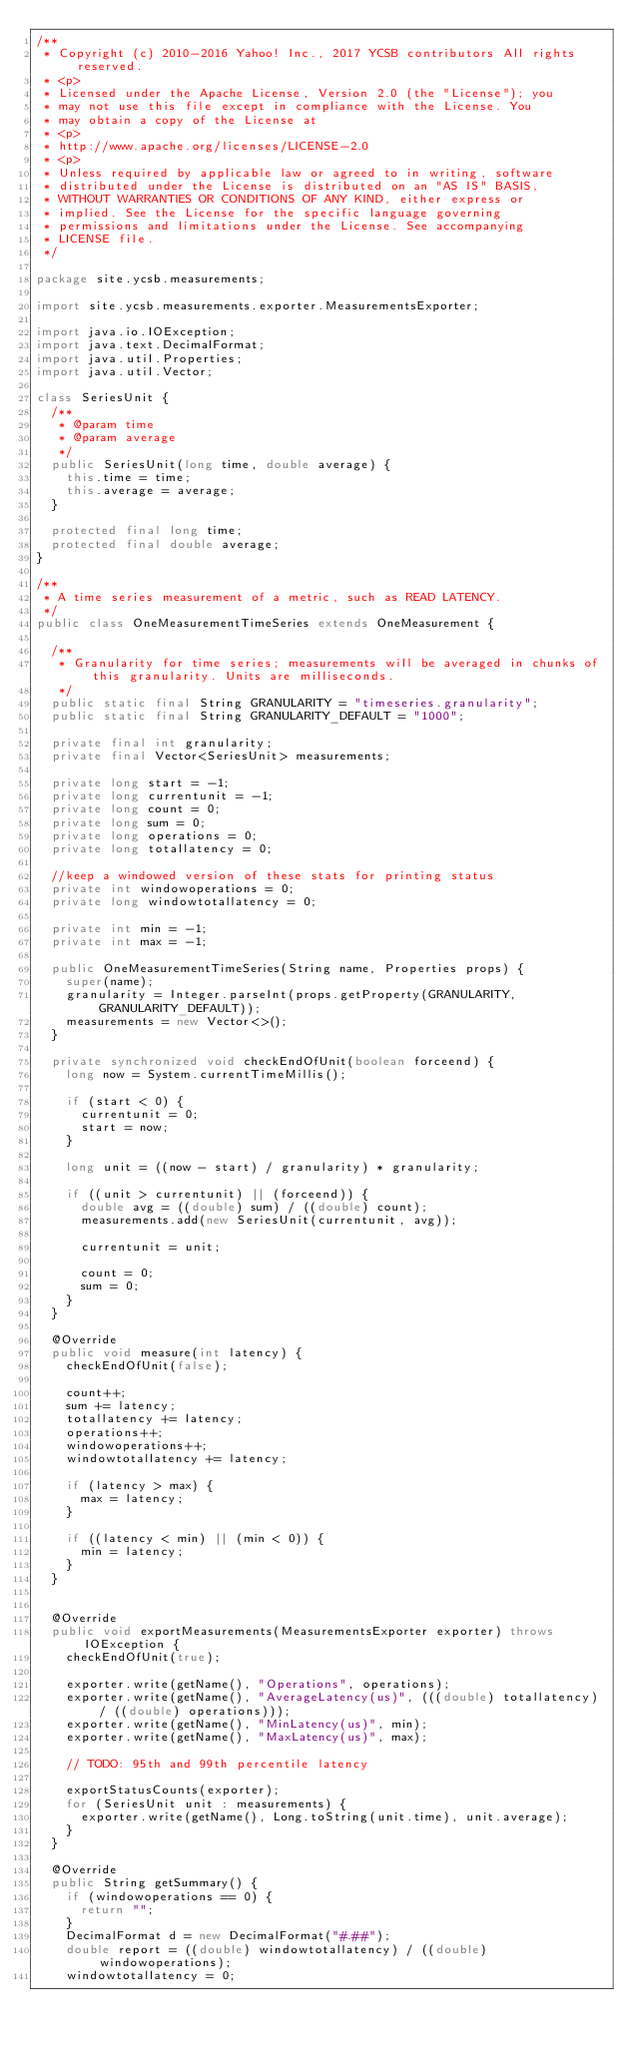Convert code to text. <code><loc_0><loc_0><loc_500><loc_500><_Java_>/**
 * Copyright (c) 2010-2016 Yahoo! Inc., 2017 YCSB contributors All rights reserved.
 * <p>
 * Licensed under the Apache License, Version 2.0 (the "License"); you
 * may not use this file except in compliance with the License. You
 * may obtain a copy of the License at
 * <p>
 * http://www.apache.org/licenses/LICENSE-2.0
 * <p>
 * Unless required by applicable law or agreed to in writing, software
 * distributed under the License is distributed on an "AS IS" BASIS,
 * WITHOUT WARRANTIES OR CONDITIONS OF ANY KIND, either express or
 * implied. See the License for the specific language governing
 * permissions and limitations under the License. See accompanying
 * LICENSE file.
 */

package site.ycsb.measurements;

import site.ycsb.measurements.exporter.MeasurementsExporter;

import java.io.IOException;
import java.text.DecimalFormat;
import java.util.Properties;
import java.util.Vector;

class SeriesUnit {
  /**
   * @param time
   * @param average
   */
  public SeriesUnit(long time, double average) {
    this.time = time;
    this.average = average;
  }

  protected final long time;
  protected final double average;
}

/**
 * A time series measurement of a metric, such as READ LATENCY.
 */
public class OneMeasurementTimeSeries extends OneMeasurement {

  /**
   * Granularity for time series; measurements will be averaged in chunks of this granularity. Units are milliseconds.
   */
  public static final String GRANULARITY = "timeseries.granularity";
  public static final String GRANULARITY_DEFAULT = "1000";

  private final int granularity;
  private final Vector<SeriesUnit> measurements;

  private long start = -1;
  private long currentunit = -1;
  private long count = 0;
  private long sum = 0;
  private long operations = 0;
  private long totallatency = 0;

  //keep a windowed version of these stats for printing status
  private int windowoperations = 0;
  private long windowtotallatency = 0;

  private int min = -1;
  private int max = -1;

  public OneMeasurementTimeSeries(String name, Properties props) {
    super(name);
    granularity = Integer.parseInt(props.getProperty(GRANULARITY, GRANULARITY_DEFAULT));
    measurements = new Vector<>();
  }

  private synchronized void checkEndOfUnit(boolean forceend) {
    long now = System.currentTimeMillis();

    if (start < 0) {
      currentunit = 0;
      start = now;
    }

    long unit = ((now - start) / granularity) * granularity;

    if ((unit > currentunit) || (forceend)) {
      double avg = ((double) sum) / ((double) count);
      measurements.add(new SeriesUnit(currentunit, avg));

      currentunit = unit;

      count = 0;
      sum = 0;
    }
  }

  @Override
  public void measure(int latency) {
    checkEndOfUnit(false);

    count++;
    sum += latency;
    totallatency += latency;
    operations++;
    windowoperations++;
    windowtotallatency += latency;

    if (latency > max) {
      max = latency;
    }

    if ((latency < min) || (min < 0)) {
      min = latency;
    }
  }


  @Override
  public void exportMeasurements(MeasurementsExporter exporter) throws IOException {
    checkEndOfUnit(true);

    exporter.write(getName(), "Operations", operations);
    exporter.write(getName(), "AverageLatency(us)", (((double) totallatency) / ((double) operations)));
    exporter.write(getName(), "MinLatency(us)", min);
    exporter.write(getName(), "MaxLatency(us)", max);

    // TODO: 95th and 99th percentile latency

    exportStatusCounts(exporter);
    for (SeriesUnit unit : measurements) {
      exporter.write(getName(), Long.toString(unit.time), unit.average);
    }
  }

  @Override
  public String getSummary() {
    if (windowoperations == 0) {
      return "";
    }
    DecimalFormat d = new DecimalFormat("#.##");
    double report = ((double) windowtotallatency) / ((double) windowoperations);
    windowtotallatency = 0;</code> 